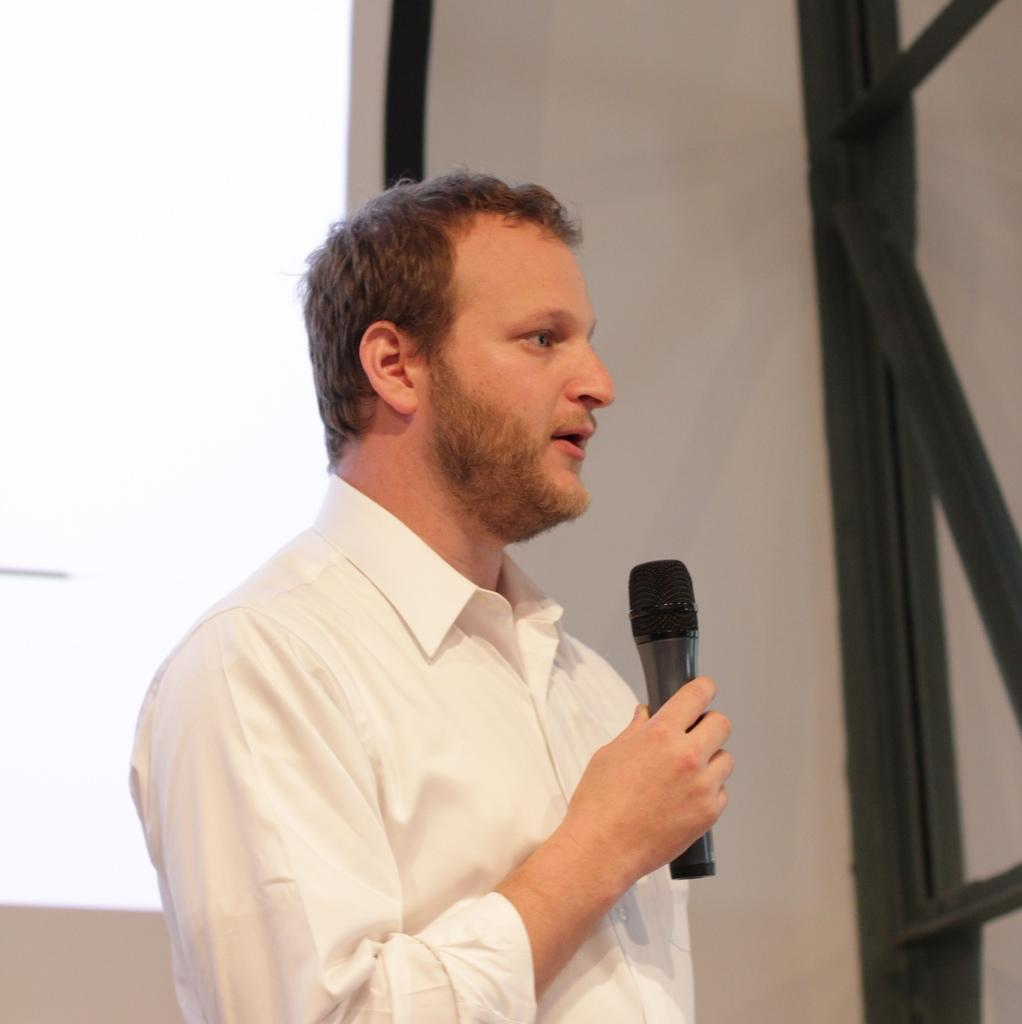What is the main subject of the picture? The main subject of the picture is a man. What is the man doing in the picture? The man is standing in the picture. What object is the man holding in his hand? The man is holding a microphone in his hand. What is the man wearing in the picture? The man is wearing a white shirt. What can be seen in the background of the picture? There is a wall in the background of the picture. What type of cherry is the man eating in the picture? There is no cherry present in the image, and the man is not eating anything. What kind of bread is the man holding in his hand instead of the microphone? The man is not holding any bread in his hand; he is holding a microphone. 